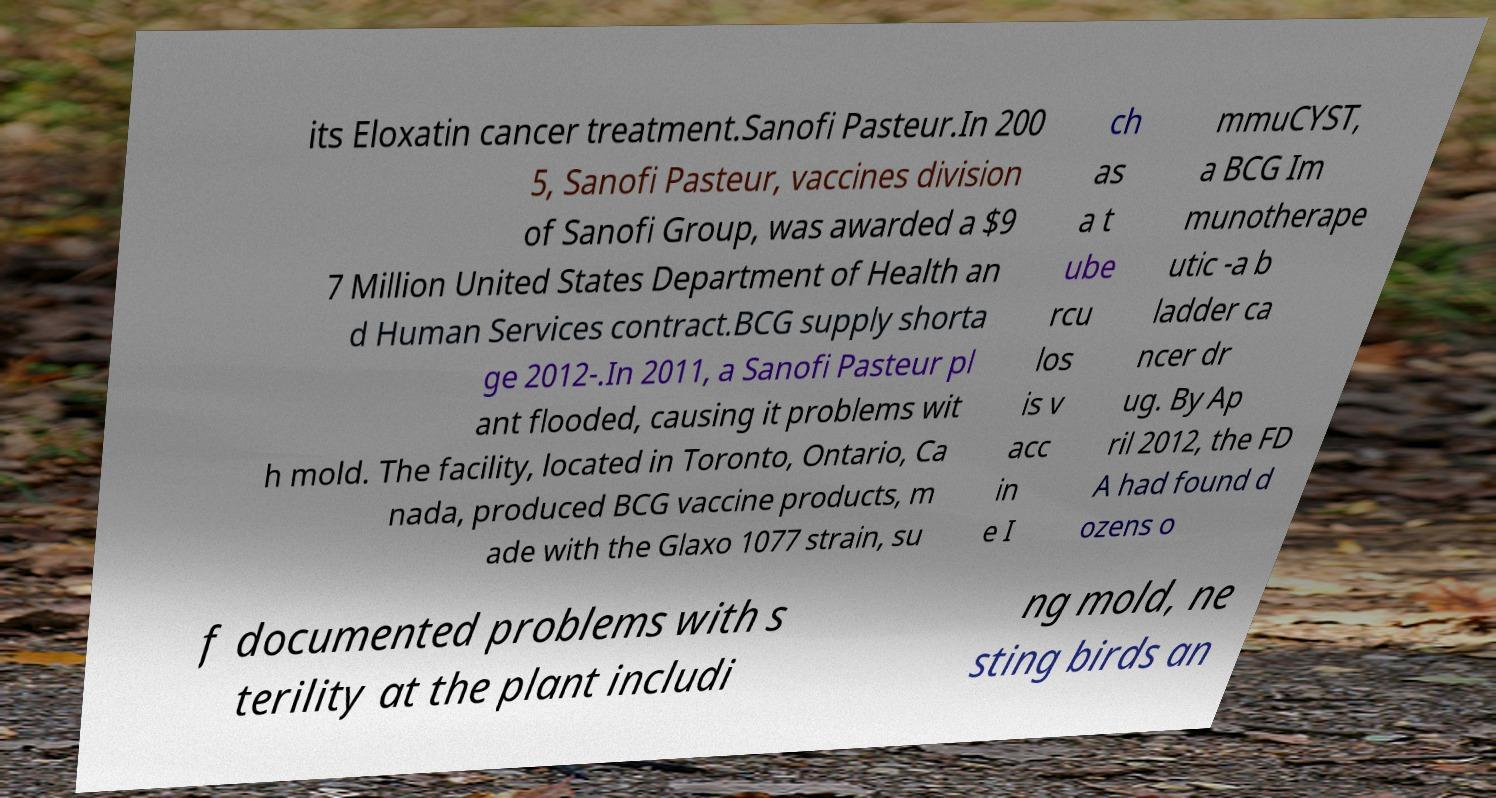Can you accurately transcribe the text from the provided image for me? its Eloxatin cancer treatment.Sanofi Pasteur.In 200 5, Sanofi Pasteur, vaccines division of Sanofi Group, was awarded a $9 7 Million United States Department of Health an d Human Services contract.BCG supply shorta ge 2012-.In 2011, a Sanofi Pasteur pl ant flooded, causing it problems wit h mold. The facility, located in Toronto, Ontario, Ca nada, produced BCG vaccine products, m ade with the Glaxo 1077 strain, su ch as a t ube rcu los is v acc in e I mmuCYST, a BCG Im munotherape utic -a b ladder ca ncer dr ug. By Ap ril 2012, the FD A had found d ozens o f documented problems with s terility at the plant includi ng mold, ne sting birds an 